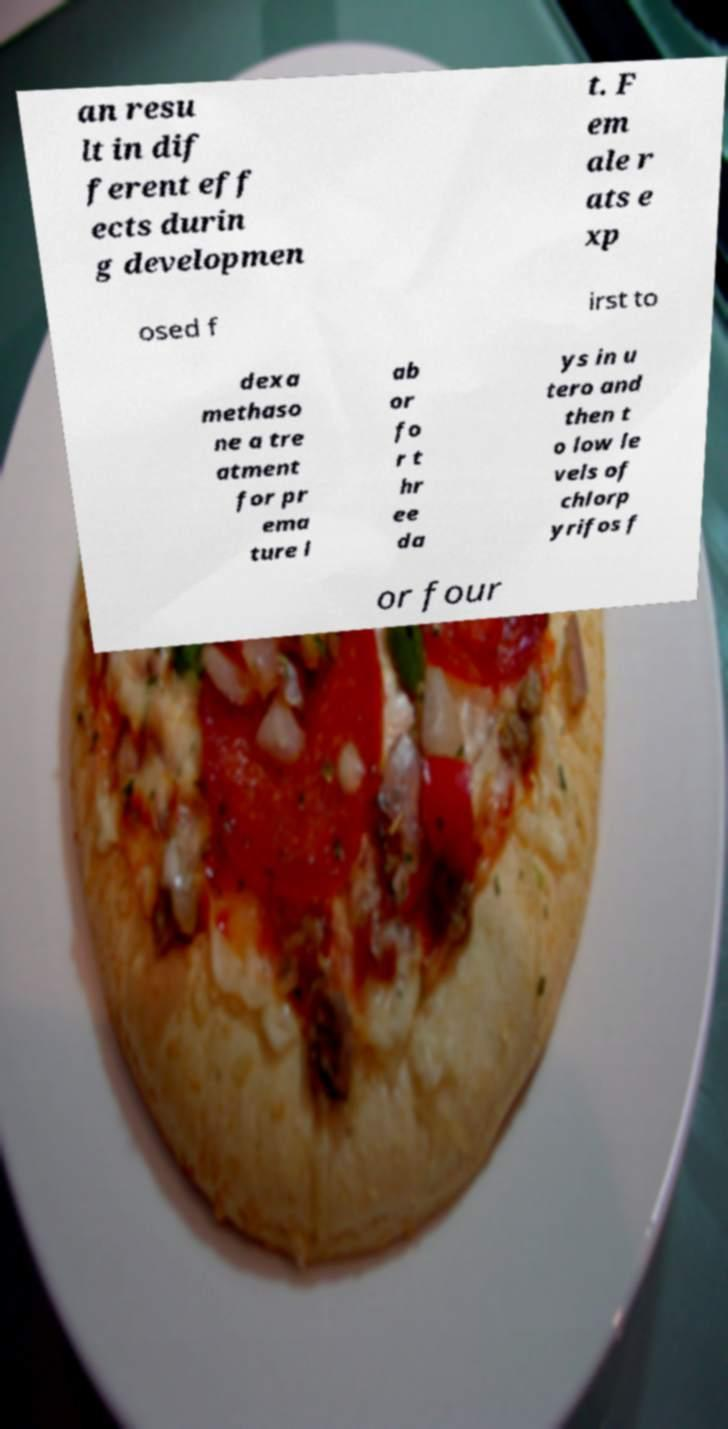Please read and relay the text visible in this image. What does it say? an resu lt in dif ferent eff ects durin g developmen t. F em ale r ats e xp osed f irst to dexa methaso ne a tre atment for pr ema ture l ab or fo r t hr ee da ys in u tero and then t o low le vels of chlorp yrifos f or four 